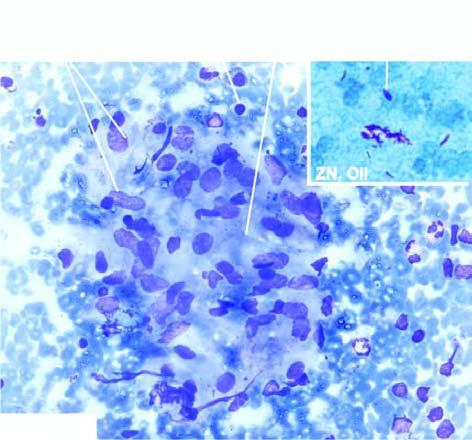who does inbox show?
Answer the question using a single word or phrase. Tuberculous lymphadenitis 